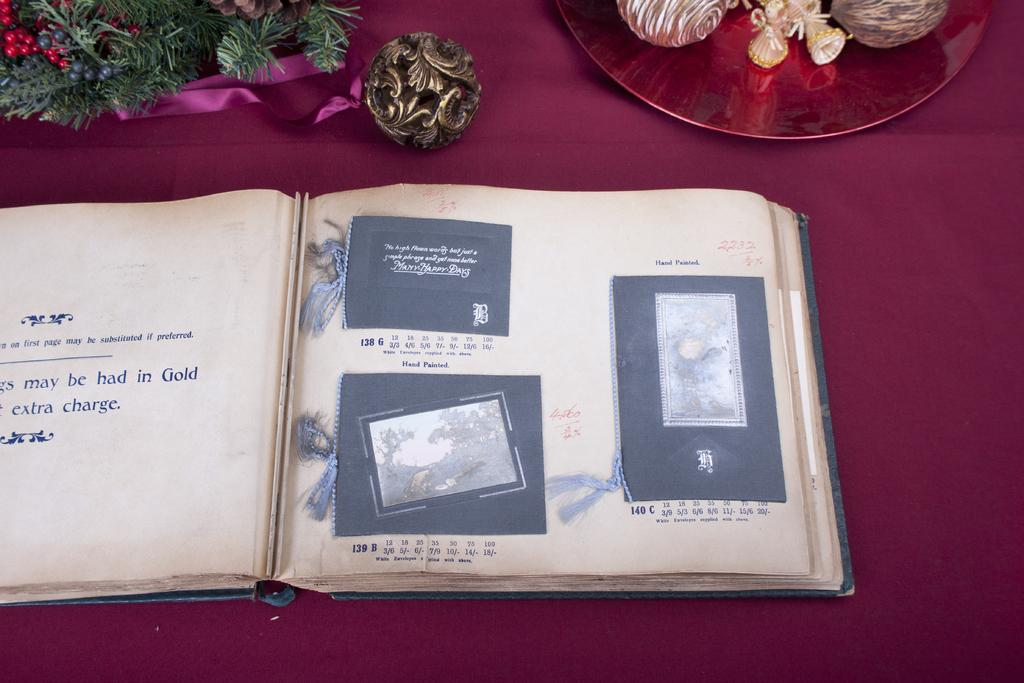Provide a one-sentence caption for the provided image. a photo album open to pages that say Hand Painted. 